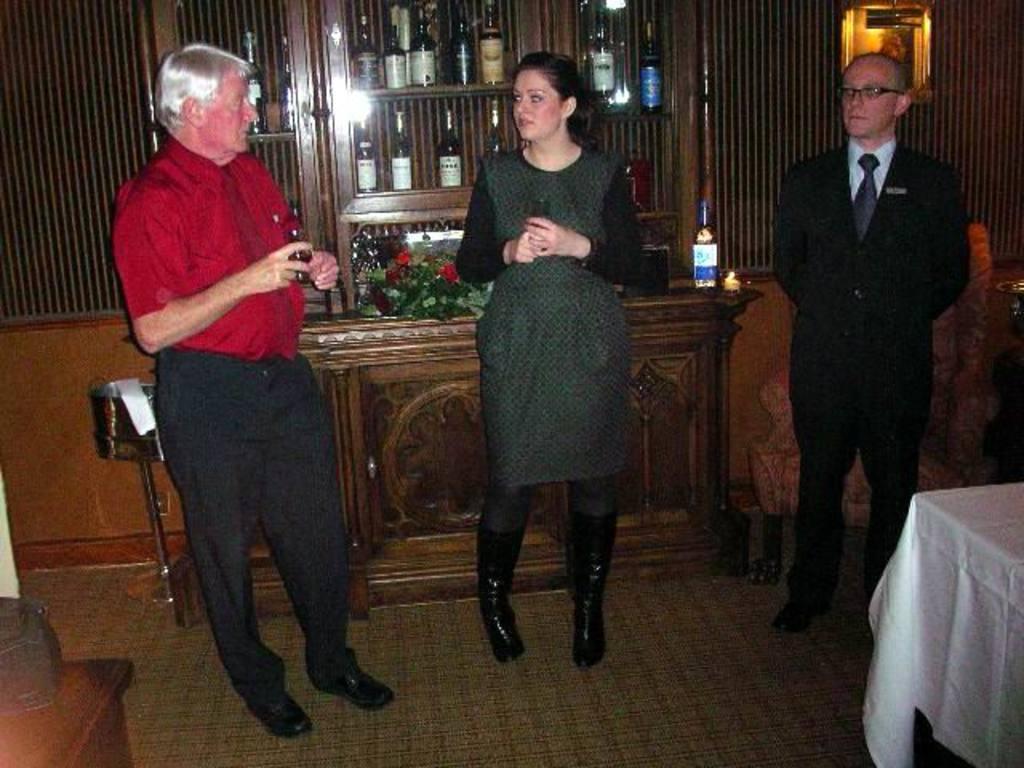Describe this image in one or two sentences. In this image I can see three people standing. These people are wearing the different color dresses. To the back of these people I can see the bouquet with red color flowers and the wine bottle on the table. To the right I can see the white color sheet on the table. And there is a chair at the back of one person. 